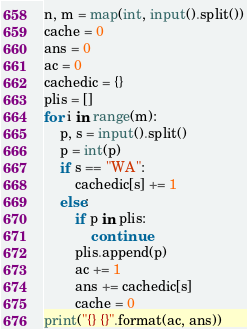<code> <loc_0><loc_0><loc_500><loc_500><_Python_>n, m = map(int, input().split())
cache = 0
ans = 0
ac = 0
cachedic = {}
plis = []
for i in range(m):
    p, s = input().split()
    p = int(p)
    if s == "WA":
        cachedic[s] += 1
    else:
        if p in plis:
            continue
        plis.append(p)
        ac += 1
        ans += cachedic[s]
        cache = 0
print("{} {}".format(ac, ans))
</code> 